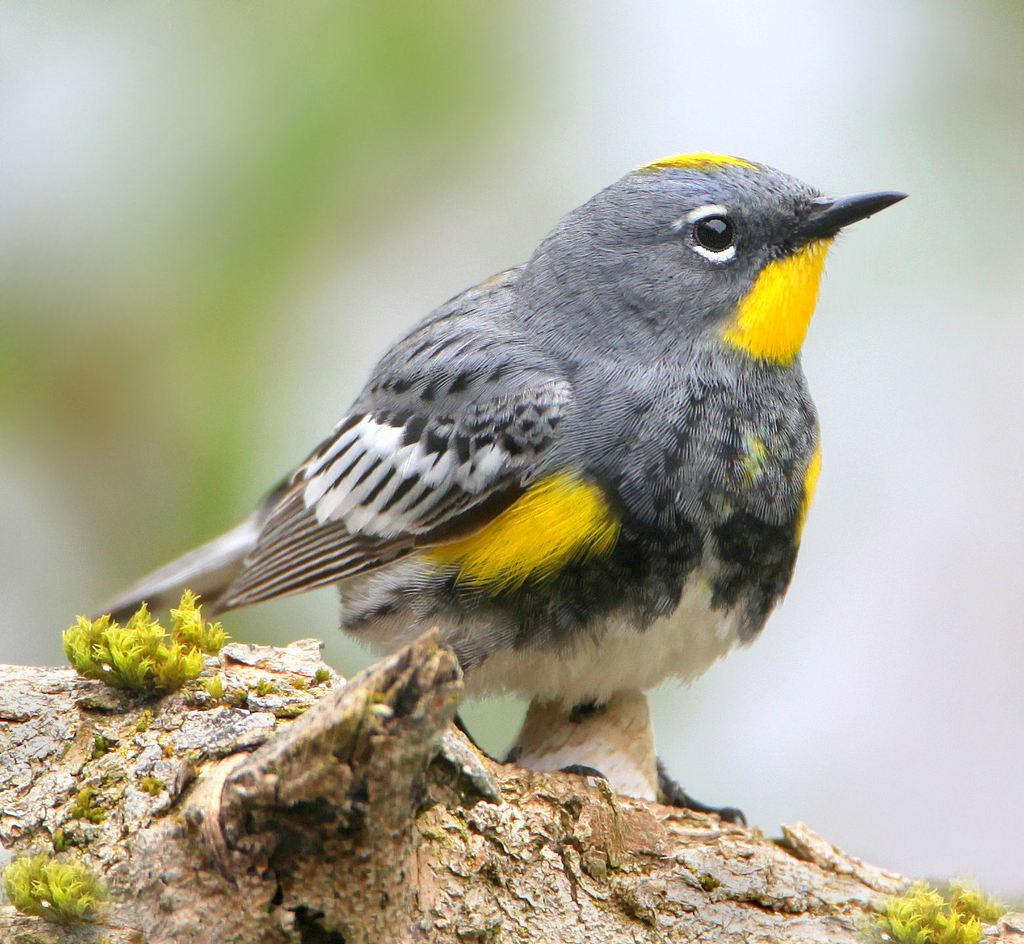What type of animal can be seen in the image? There is a bird in the image. Where is the bird located? The bird is on a branch. Can you describe the background of the image? The background of the image is blurred. What type of iron is the bird using to mark its territory in the image? There is no iron present in the image, and the bird is not marking its territory. 